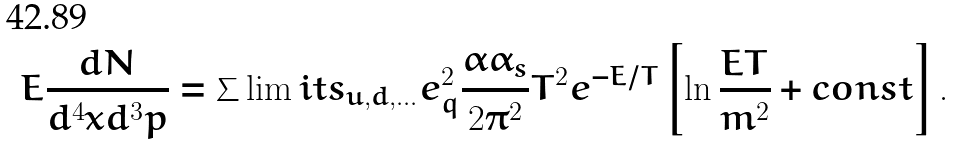Convert formula to latex. <formula><loc_0><loc_0><loc_500><loc_500>E \frac { d N } { d ^ { 4 } x d ^ { 3 } p } = \sum \lim i t s _ { u , d , \dots } e ^ { 2 } _ { q } \frac { \alpha \alpha _ { s } } { 2 \pi ^ { 2 } } T ^ { 2 } e ^ { - E / T } \left [ \ln \frac { E T } { m ^ { 2 } } + c o n s t \right ] .</formula> 